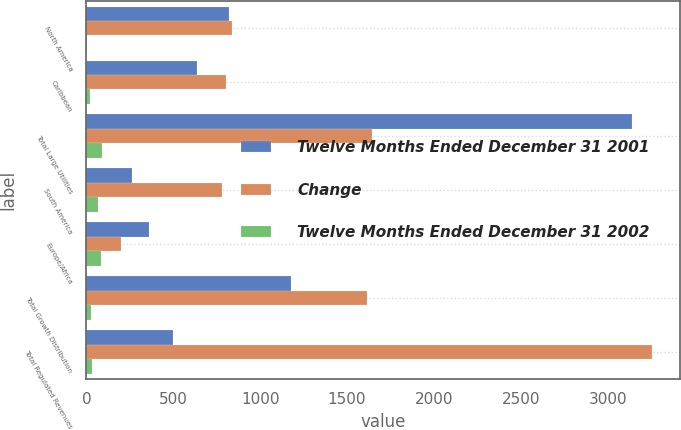Convert chart to OTSL. <chart><loc_0><loc_0><loc_500><loc_500><stacked_bar_chart><ecel><fcel>North America<fcel>Caribbean<fcel>Total Large Utilities<fcel>South America<fcel>Europe/Africa<fcel>Total Growth Distribution<fcel>Total Regulated Revenues<nl><fcel>Twelve Months Ended December 31 2001<fcel>818<fcel>634<fcel>3137<fcel>263<fcel>358<fcel>1180<fcel>496<nl><fcel>Change<fcel>836<fcel>806<fcel>1642<fcel>781<fcel>197<fcel>1613<fcel>3255<nl><fcel>Twelve Months Ended December 31 2002<fcel>2<fcel>21<fcel>91<fcel>66<fcel>82<fcel>27<fcel>33<nl></chart> 